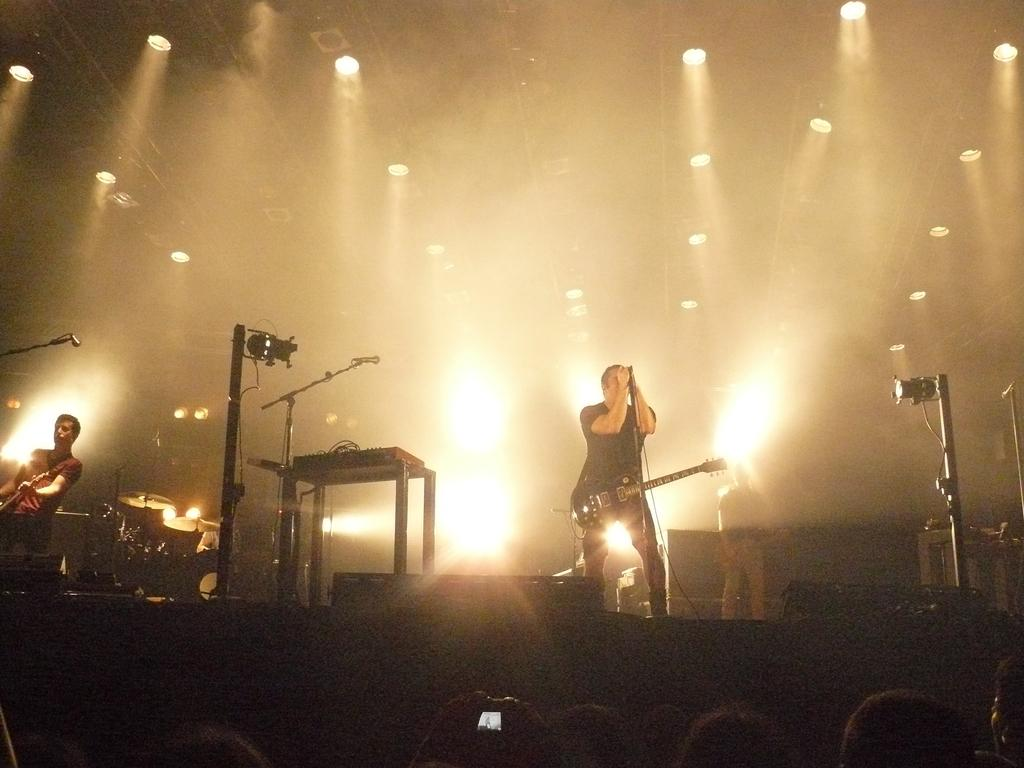Who or what can be seen in the image? There are people in the image. What are the people doing in the image? The people are standing in the image. What object are the people holding in their hands? The people are holding a guitar in their hands. What type of waste can be seen on the ground in the image? There is no waste present in the image; it only features people standing and holding a guitar. 